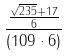<formula> <loc_0><loc_0><loc_500><loc_500>\frac { \frac { \sqrt { 2 3 5 } + 1 7 } { 6 } } { ( 1 0 9 \cdot 6 ) }</formula> 